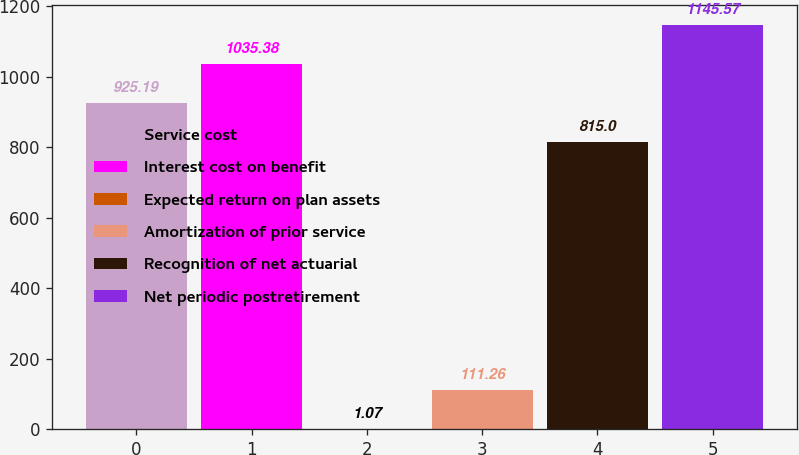Convert chart. <chart><loc_0><loc_0><loc_500><loc_500><bar_chart><fcel>Service cost<fcel>Interest cost on benefit<fcel>Expected return on plan assets<fcel>Amortization of prior service<fcel>Recognition of net actuarial<fcel>Net periodic postretirement<nl><fcel>925.19<fcel>1035.38<fcel>1.07<fcel>111.26<fcel>815<fcel>1145.57<nl></chart> 